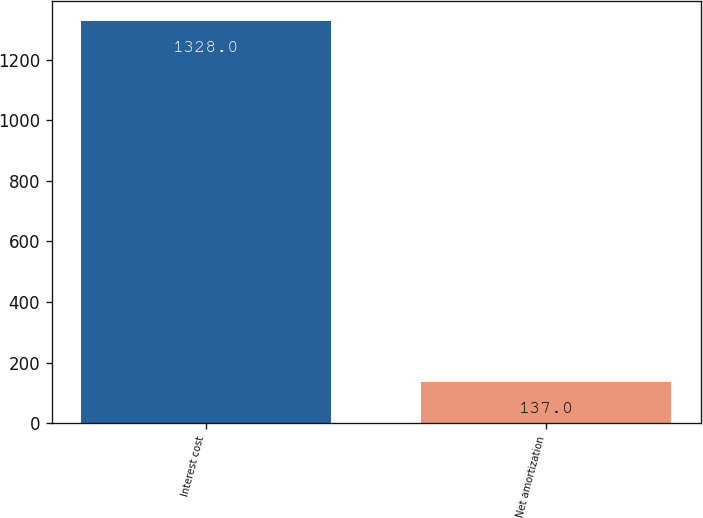Convert chart to OTSL. <chart><loc_0><loc_0><loc_500><loc_500><bar_chart><fcel>Interest cost<fcel>Net amortization<nl><fcel>1328<fcel>137<nl></chart> 